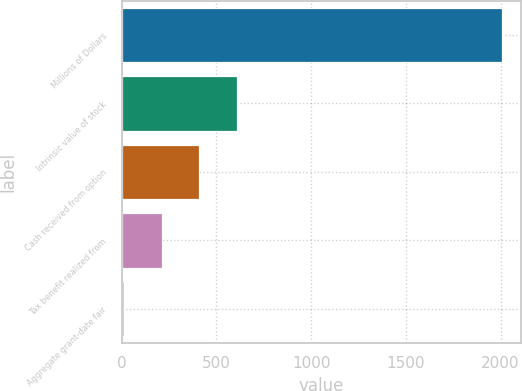Convert chart. <chart><loc_0><loc_0><loc_500><loc_500><bar_chart><fcel>Millions of Dollars<fcel>Intrinsic value of stock<fcel>Cash received from option<fcel>Tax benefit realized from<fcel>Aggregate grant-date fair<nl><fcel>2007<fcel>609.8<fcel>410.2<fcel>210.6<fcel>11<nl></chart> 